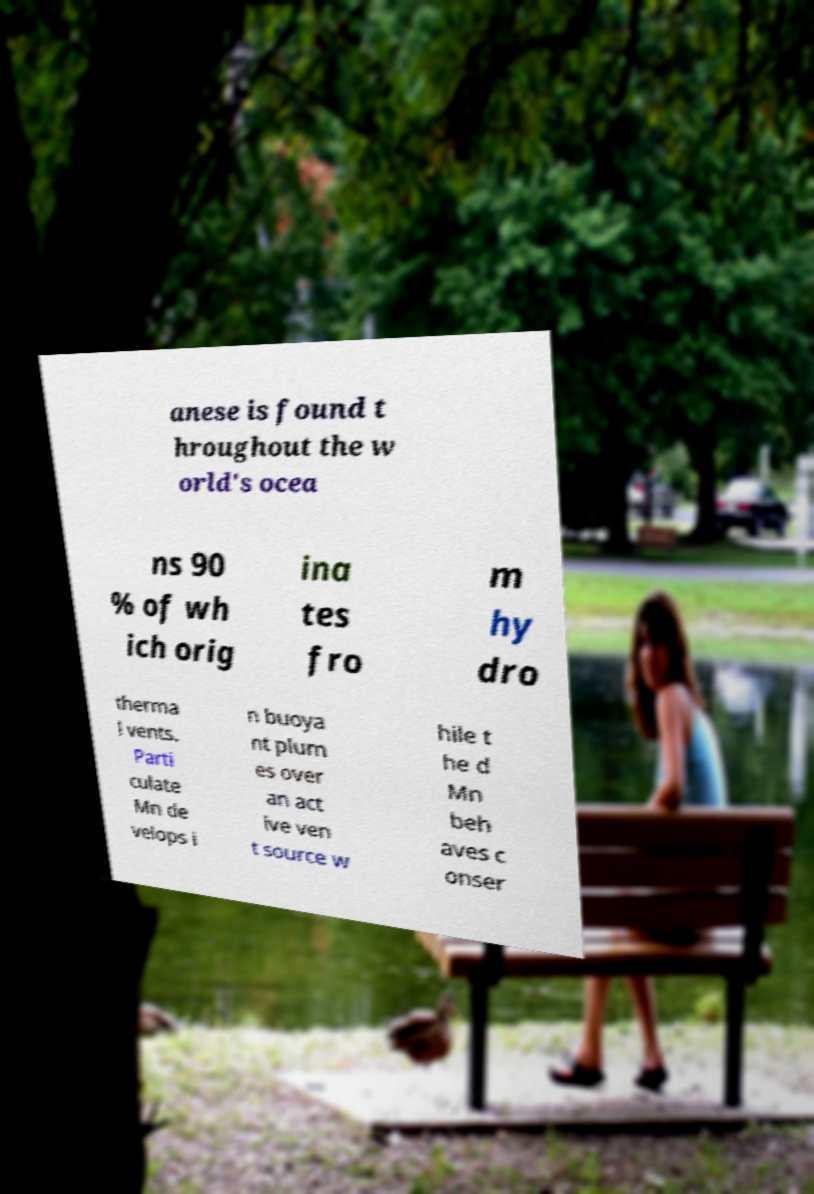Could you extract and type out the text from this image? anese is found t hroughout the w orld's ocea ns 90 % of wh ich orig ina tes fro m hy dro therma l vents. Parti culate Mn de velops i n buoya nt plum es over an act ive ven t source w hile t he d Mn beh aves c onser 